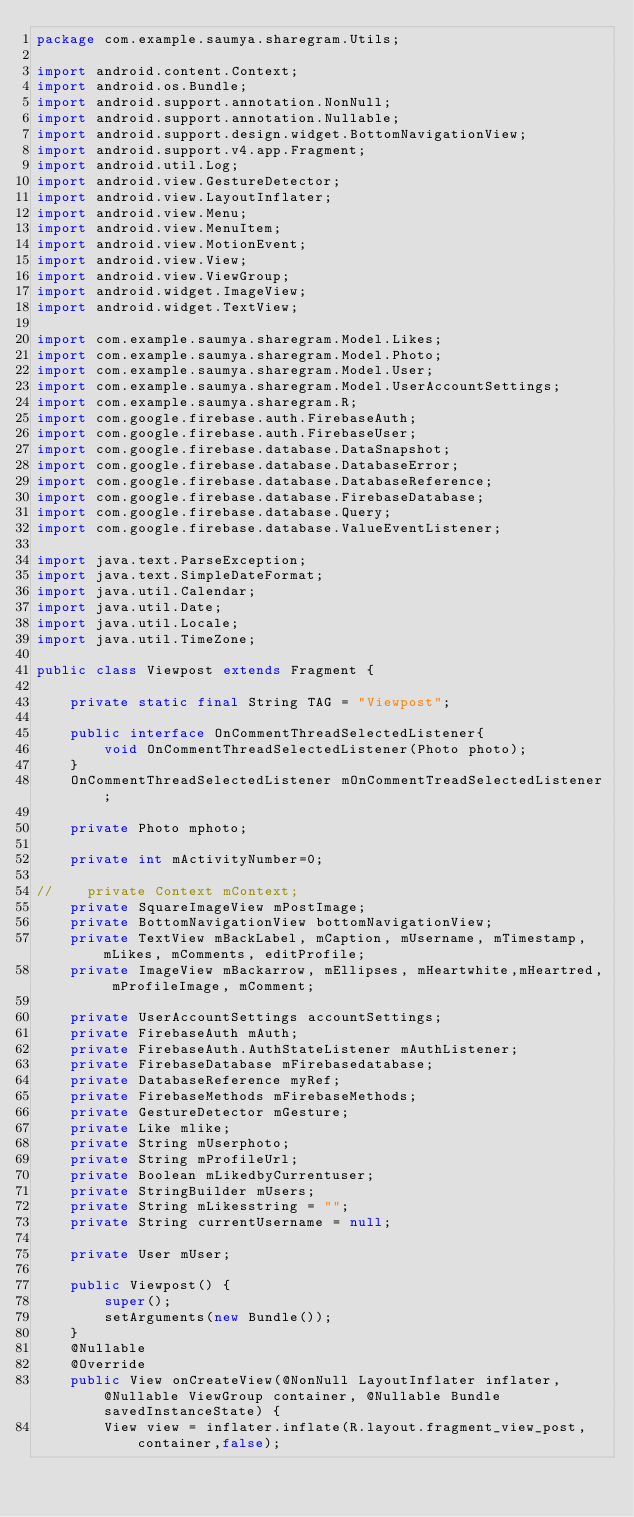<code> <loc_0><loc_0><loc_500><loc_500><_Java_>package com.example.saumya.sharegram.Utils;

import android.content.Context;
import android.os.Bundle;
import android.support.annotation.NonNull;
import android.support.annotation.Nullable;
import android.support.design.widget.BottomNavigationView;
import android.support.v4.app.Fragment;
import android.util.Log;
import android.view.GestureDetector;
import android.view.LayoutInflater;
import android.view.Menu;
import android.view.MenuItem;
import android.view.MotionEvent;
import android.view.View;
import android.view.ViewGroup;
import android.widget.ImageView;
import android.widget.TextView;

import com.example.saumya.sharegram.Model.Likes;
import com.example.saumya.sharegram.Model.Photo;
import com.example.saumya.sharegram.Model.User;
import com.example.saumya.sharegram.Model.UserAccountSettings;
import com.example.saumya.sharegram.R;
import com.google.firebase.auth.FirebaseAuth;
import com.google.firebase.auth.FirebaseUser;
import com.google.firebase.database.DataSnapshot;
import com.google.firebase.database.DatabaseError;
import com.google.firebase.database.DatabaseReference;
import com.google.firebase.database.FirebaseDatabase;
import com.google.firebase.database.Query;
import com.google.firebase.database.ValueEventListener;

import java.text.ParseException;
import java.text.SimpleDateFormat;
import java.util.Calendar;
import java.util.Date;
import java.util.Locale;
import java.util.TimeZone;

public class Viewpost extends Fragment {

    private static final String TAG = "Viewpost";

    public interface OnCommentThreadSelectedListener{
        void OnCommentThreadSelectedListener(Photo photo);
    }
    OnCommentThreadSelectedListener mOnCommentTreadSelectedListener;

    private Photo mphoto;

    private int mActivityNumber=0;

//    private Context mContext;
    private SquareImageView mPostImage;
    private BottomNavigationView bottomNavigationView;
    private TextView mBackLabel, mCaption, mUsername, mTimestamp, mLikes, mComments, editProfile;
    private ImageView mBackarrow, mEllipses, mHeartwhite,mHeartred, mProfileImage, mComment;

    private UserAccountSettings accountSettings;
    private FirebaseAuth mAuth;
    private FirebaseAuth.AuthStateListener mAuthListener;
    private FirebaseDatabase mFirebasedatabase;
    private DatabaseReference myRef;
    private FirebaseMethods mFirebaseMethods;
    private GestureDetector mGesture;
    private Like mlike;
    private String mUserphoto;
    private String mProfileUrl;
    private Boolean mLikedbyCurrentuser;
    private StringBuilder mUsers;
    private String mLikesstring = "";
    private String currentUsername = null;

    private User mUser;

    public Viewpost() {
        super();
        setArguments(new Bundle());
    }
    @Nullable
    @Override
    public View onCreateView(@NonNull LayoutInflater inflater, @Nullable ViewGroup container, @Nullable Bundle savedInstanceState) {
        View view = inflater.inflate(R.layout.fragment_view_post,container,false);</code> 